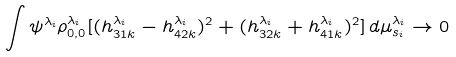Convert formula to latex. <formula><loc_0><loc_0><loc_500><loc_500>& \int \psi ^ { \lambda _ { i } } \rho ^ { \lambda _ { i } } _ { 0 , 0 } [ ( h ^ { \lambda _ { i } } _ { 3 1 k } - h ^ { \lambda _ { i } } _ { 4 2 k } ) ^ { 2 } + ( h ^ { \lambda _ { i } } _ { 3 2 k } + h ^ { \lambda _ { i } } _ { 4 1 k } ) ^ { 2 } ] \, d \mu _ { s _ { i } } ^ { \lambda _ { i } } \rightarrow 0</formula> 